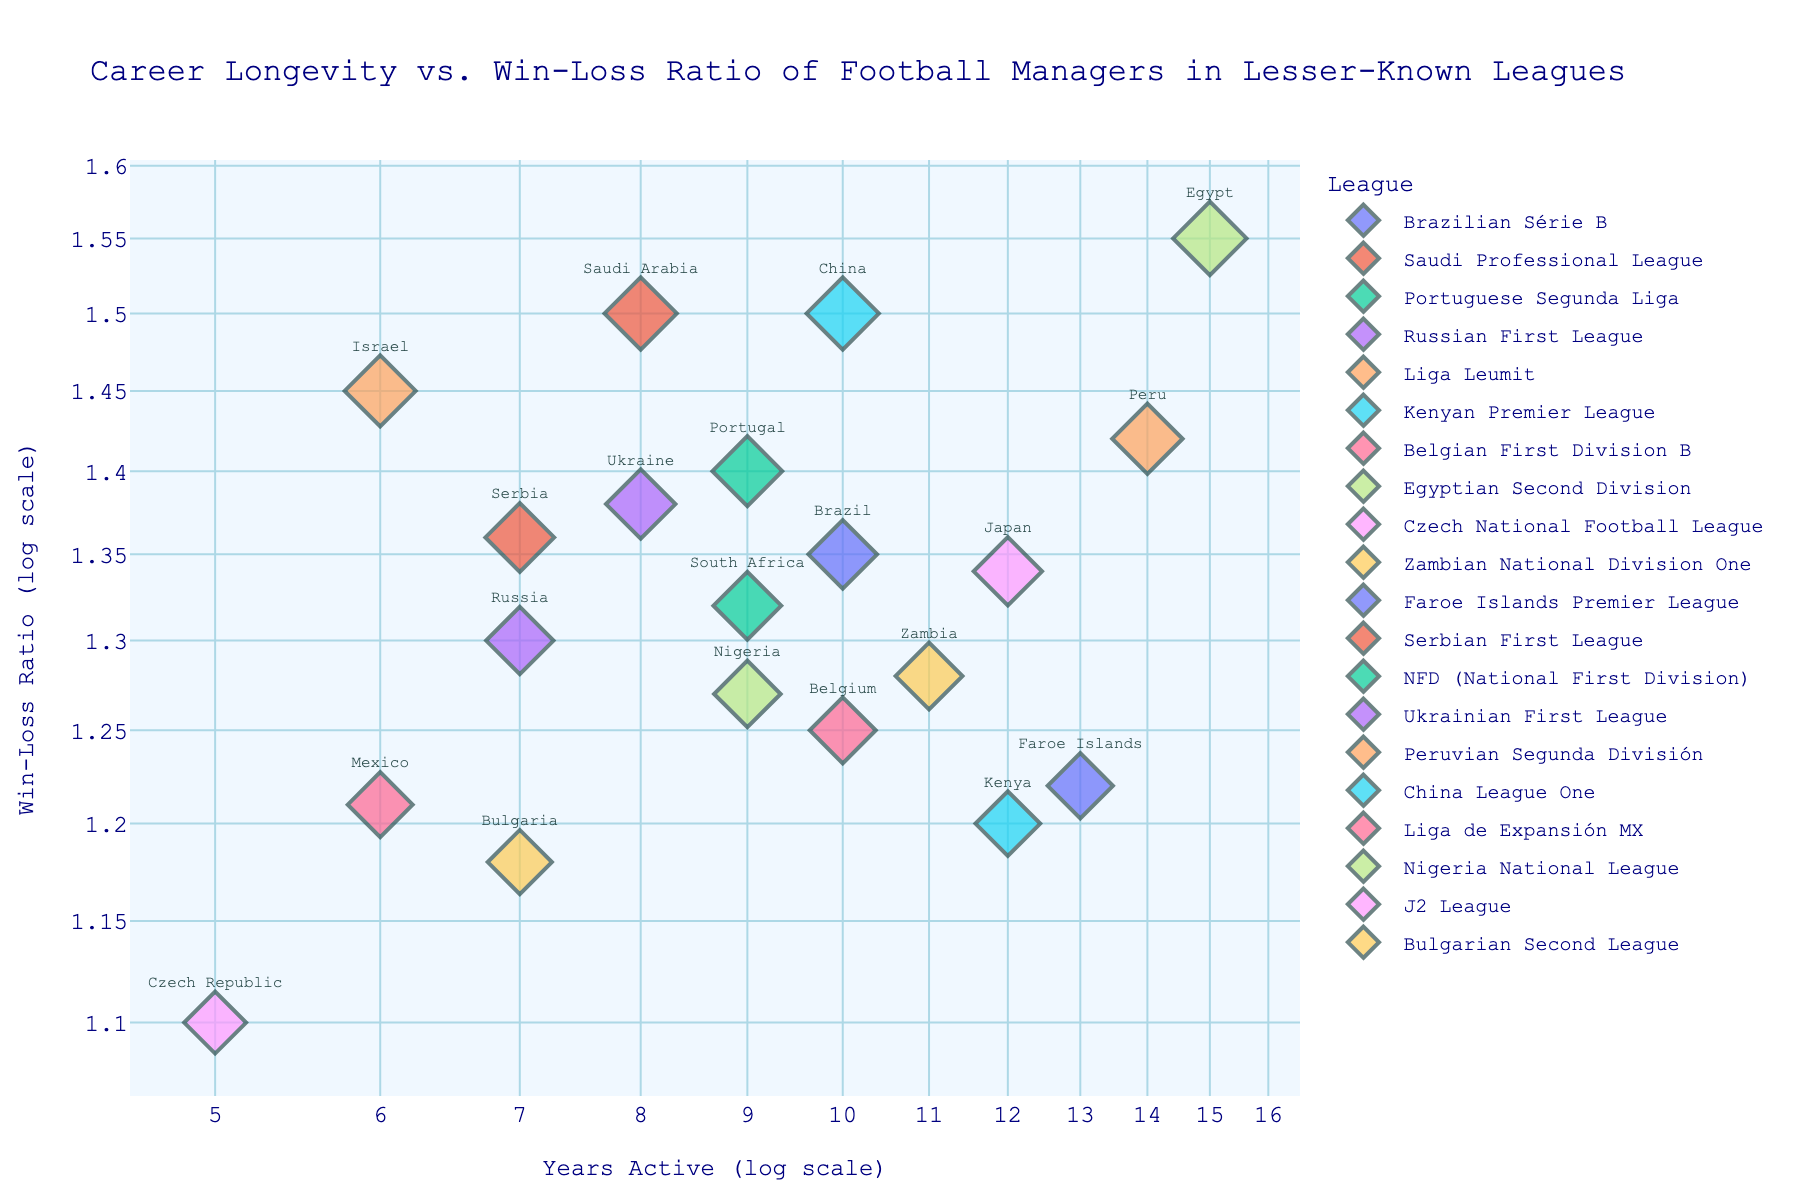What is the title of the plot? The title is typically located at the top of the plot. Here, it reads "Career Longevity vs. Win-Loss Ratio of Football Managers in Lesser-Known Leagues."
Answer: Career Longevity vs. Win-Loss Ratio of Football Managers in Lesser-Known Leagues Which manager has the highest win-loss ratio? Inspect the y-axis values and look for the highest point on the scatter plot. Hover names or markers' positions will indicate the respective manager. Hassan Shehata, with a win-loss ratio of 1.55, is at the highest point.
Answer: Hassan Shehata What is the range of the x-axis (Years Active log scale)? The range can be seen from the lowest and highest values on the x-axis. Here, they range approximately from 1 to 15 years on a log scale.
Answer: 1 to 15 years How many managers have been active for more than 10 years? By examining points along the x-axis beyond 10 years, count the relevant data points visually. There are four managers (Francis Kimanzi, Hassan Shehata, Lars Olsen, Kalusha Bwalya).
Answer: Four Which country does the manager with the longest career come from? Identify the point farthest right on the x-axis; the hover text will show Hassan Shehata from Egypt with 15 years is the farthest right.
Answer: Egypt How do the win-loss ratios compare between managers from the Faroe Islands and Zambia? Locate managers from both countries. Lars Olsen from the Faroe Islands has a win-loss ratio of 1.22, while Kalusha Bwalya from Zambia has 1.28. Compare these values.
Answer: Kalusha Bwalya > Lars Olsen What is the relationship between the length of career and win-loss ratio evident in this plot? Observe the general trend or distribution of points. It’s visible that there is no explicit linear trend, but rather a scattered distribution indicating no clear correlation.
Answer: No clear correlation Which league has the most managers represented in this scatter plot? Inspect the colors associated with each league in the legend and count the markers corresponding to each league color. Several leagues have an equal representation, e.g., 3 data points each for different leagues.
Answer: Multiple leagues with equal representation What is the average win-loss ratio of managers who have been active for exactly 7 years? Identify data points for 7 years on the x-axis and list the win-loss ratios: Dimitri Cheryshev (1.30), Mateja Kežman (1.36), Vasil Bozhikov (1.18). Calculate the average: (1.30 + 1.36 + 1.18)/3 = 1.28.
Answer: 1.28 Which manager has the lowest win-loss ratio and from which league? Locate the lowest point on the y-axis to find Jan Koller with a ratio of 1.10. The hover text will reveal Jan Koller from the Czech National Football League.
Answer: Jan Koller, Czech National Football League 